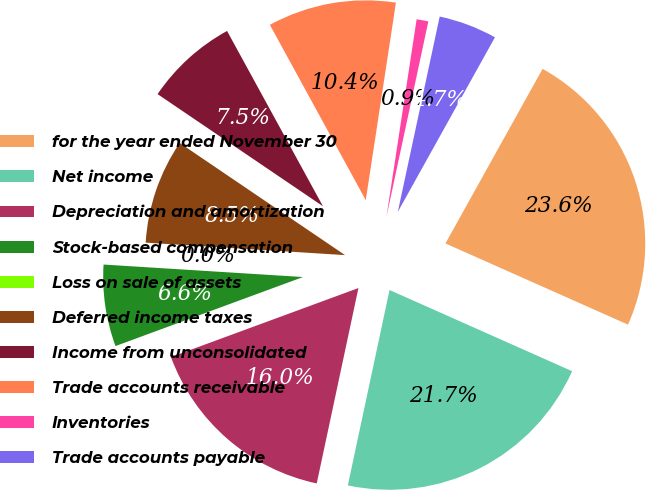Convert chart to OTSL. <chart><loc_0><loc_0><loc_500><loc_500><pie_chart><fcel>for the year ended November 30<fcel>Net income<fcel>Depreciation and amortization<fcel>Stock-based compensation<fcel>Loss on sale of assets<fcel>Deferred income taxes<fcel>Income from unconsolidated<fcel>Trade accounts receivable<fcel>Inventories<fcel>Trade accounts payable<nl><fcel>23.58%<fcel>21.69%<fcel>16.04%<fcel>6.61%<fcel>0.0%<fcel>8.49%<fcel>7.55%<fcel>10.38%<fcel>0.95%<fcel>4.72%<nl></chart> 